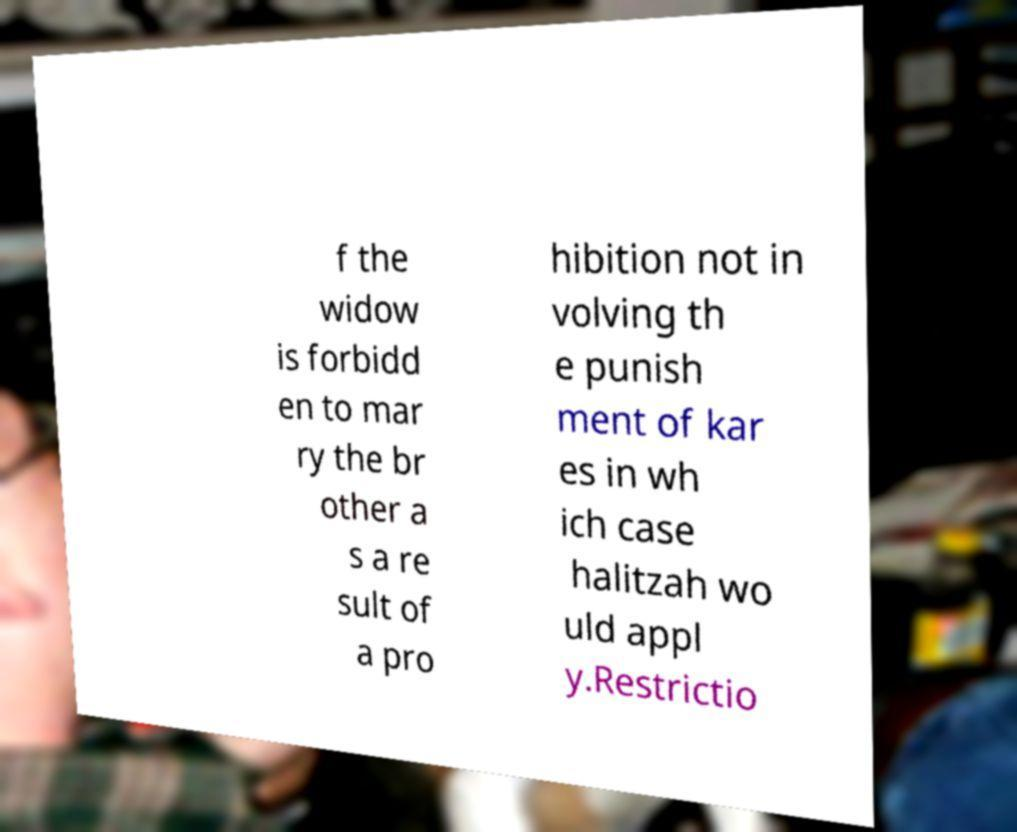Can you read and provide the text displayed in the image?This photo seems to have some interesting text. Can you extract and type it out for me? f the widow is forbidd en to mar ry the br other a s a re sult of a pro hibition not in volving th e punish ment of kar es in wh ich case halitzah wo uld appl y.Restrictio 